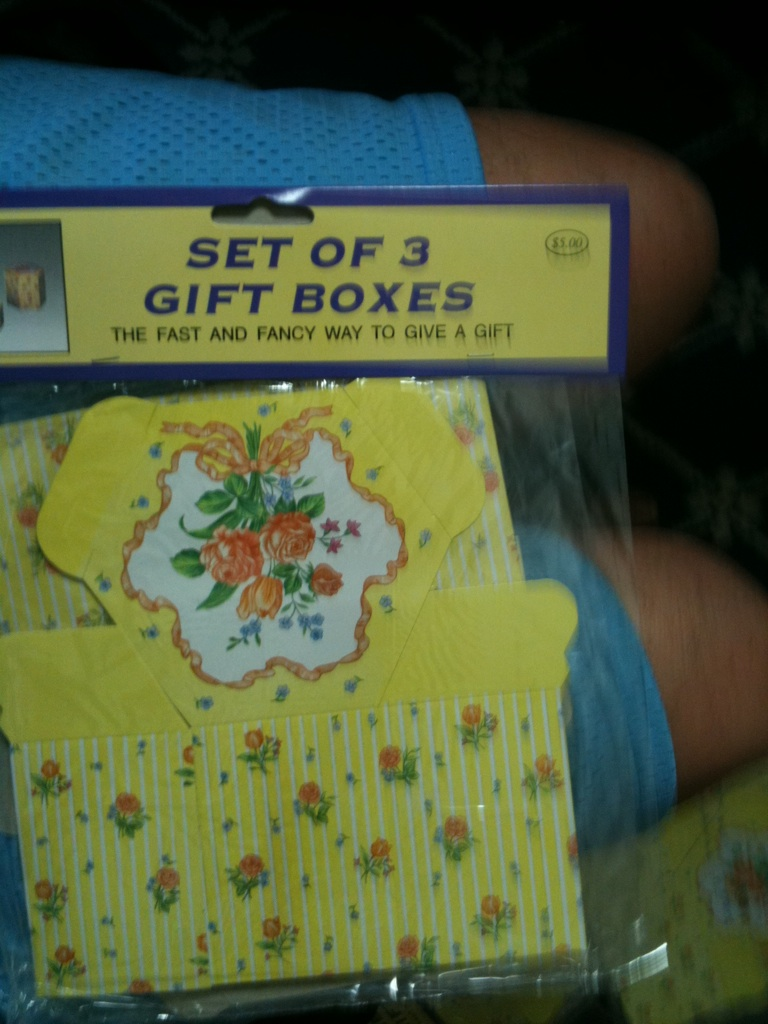How could someone use these boxes effectively for gift giving? These boxes are ideal for gift giving as they come in varying sizes, suitable for different types of gifts from jewelry to small clothing items. You can further decorate them with ribbons and tags to personalize your gifts, creating an unforgettable and thoughtful presentation. Are these boxes reusable and environmentally friendly? While the aesthetic value of these boxes makes them great for reuse as decorative storage or keepsake boxes, their environmental friendliness largely depends on the materials used. Generally, such paper-based products are recyclable, but it is best to refer to specific packaging labels for environmental claims. 